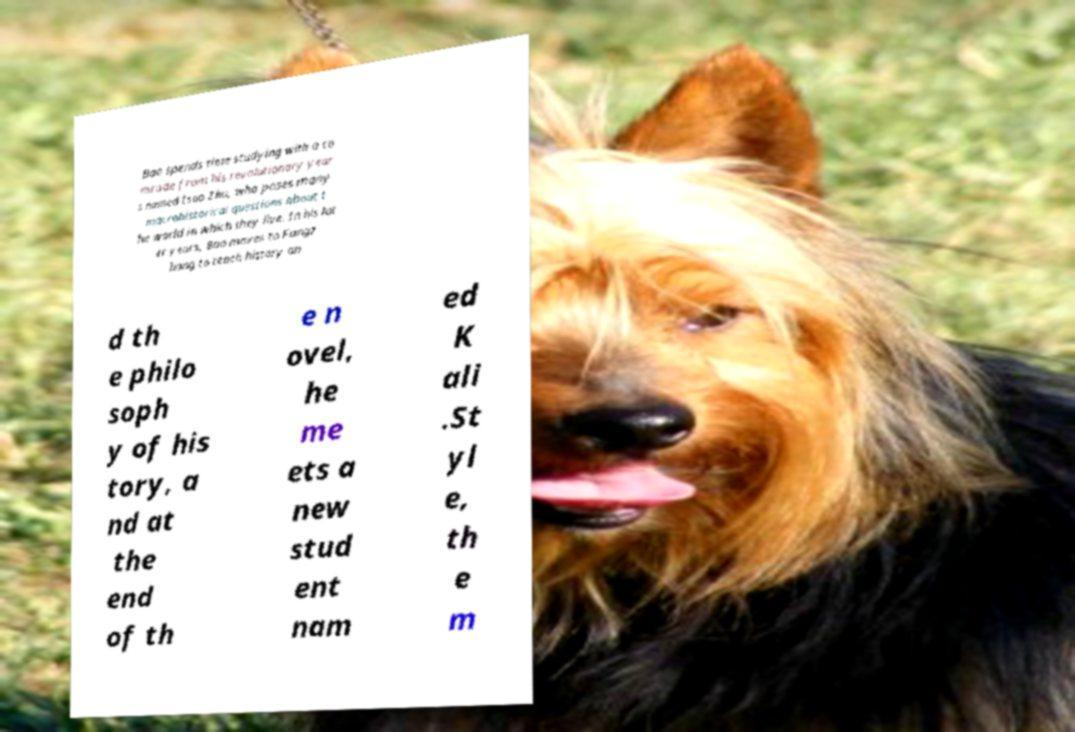Can you read and provide the text displayed in the image?This photo seems to have some interesting text. Can you extract and type it out for me? Bao spends time studying with a co mrade from his revolutionary year s named Isao Zhu, who poses many macrohistorical questions about t he world in which they live. In his lat er years, Bao moves to Fangz hang to teach history an d th e philo soph y of his tory, a nd at the end of th e n ovel, he me ets a new stud ent nam ed K ali .St yl e, th e m 